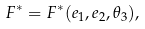<formula> <loc_0><loc_0><loc_500><loc_500>F ^ { * } = F ^ { * } ( e _ { 1 } , e _ { 2 } , \theta _ { 3 } ) ,</formula> 